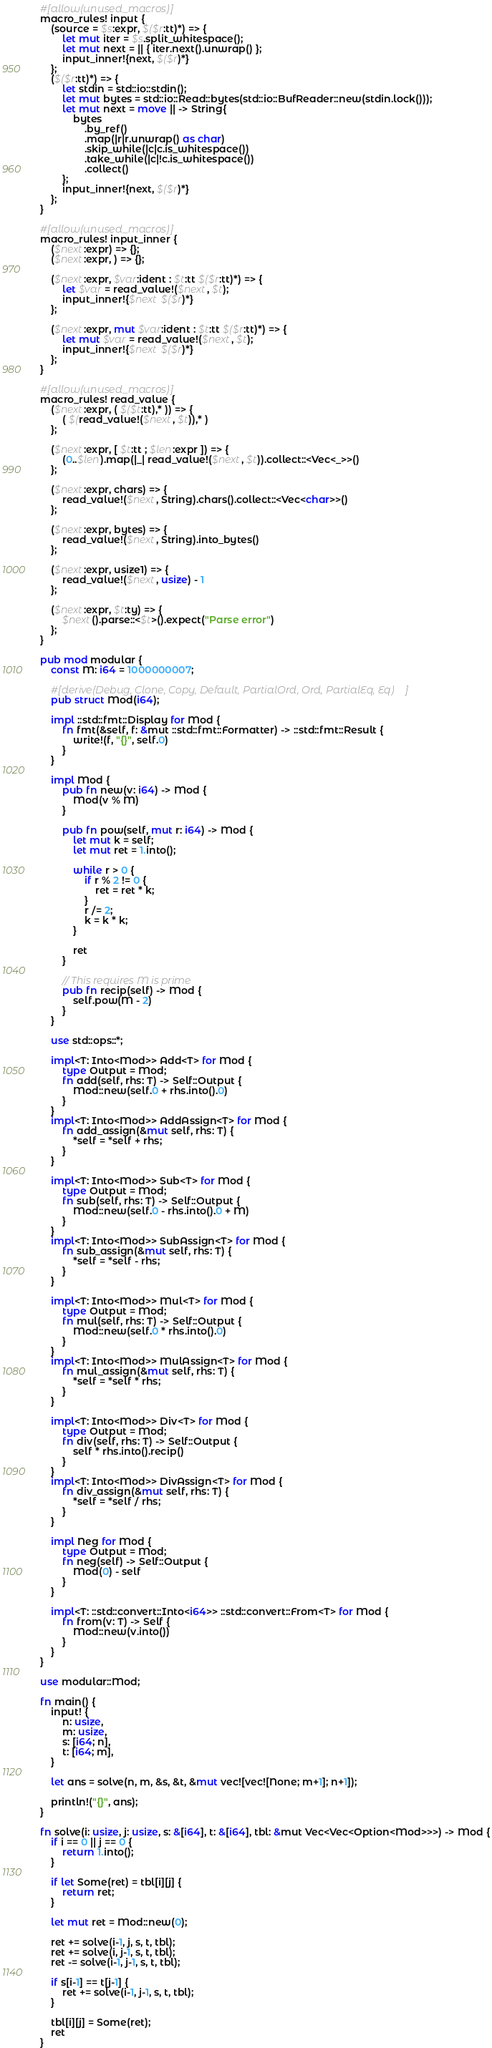Convert code to text. <code><loc_0><loc_0><loc_500><loc_500><_Rust_>#[allow(unused_macros)]
macro_rules! input {
    (source = $s:expr, $($r:tt)*) => {
        let mut iter = $s.split_whitespace();
        let mut next = || { iter.next().unwrap() };
        input_inner!{next, $($r)*}
    };
    ($($r:tt)*) => {
        let stdin = std::io::stdin();
        let mut bytes = std::io::Read::bytes(std::io::BufReader::new(stdin.lock()));
        let mut next = move || -> String{
            bytes
                .by_ref()
                .map(|r|r.unwrap() as char)
                .skip_while(|c|c.is_whitespace())
                .take_while(|c|!c.is_whitespace())
                .collect()
        };
        input_inner!{next, $($r)*}
    };
}

#[allow(unused_macros)]
macro_rules! input_inner {
    ($next:expr) => {};
    ($next:expr, ) => {};

    ($next:expr, $var:ident : $t:tt $($r:tt)*) => {
        let $var = read_value!($next, $t);
        input_inner!{$next $($r)*}
    };

    ($next:expr, mut $var:ident : $t:tt $($r:tt)*) => {
        let mut $var = read_value!($next, $t);
        input_inner!{$next $($r)*}
    };
}

#[allow(unused_macros)]
macro_rules! read_value {
    ($next:expr, ( $($t:tt),* )) => {
        ( $(read_value!($next, $t)),* )
    };

    ($next:expr, [ $t:tt ; $len:expr ]) => {
        (0..$len).map(|_| read_value!($next, $t)).collect::<Vec<_>>()
    };

    ($next:expr, chars) => {
        read_value!($next, String).chars().collect::<Vec<char>>()
    };

    ($next:expr, bytes) => {
        read_value!($next, String).into_bytes()
    };

    ($next:expr, usize1) => {
        read_value!($next, usize) - 1
    };

    ($next:expr, $t:ty) => {
        $next().parse::<$t>().expect("Parse error")
    };
}

pub mod modular {
    const M: i64 = 1000000007;

    #[derive(Debug, Clone, Copy, Default, PartialOrd, Ord, PartialEq, Eq)]
    pub struct Mod(i64);

    impl ::std::fmt::Display for Mod {
        fn fmt(&self, f: &mut ::std::fmt::Formatter) -> ::std::fmt::Result {
            write!(f, "{}", self.0)
        }
    }

    impl Mod {
        pub fn new(v: i64) -> Mod {
            Mod(v % M)
        }

        pub fn pow(self, mut r: i64) -> Mod {
            let mut k = self;
            let mut ret = 1.into();

            while r > 0 {
                if r % 2 != 0 {
                    ret = ret * k;
                }
                r /= 2;
                k = k * k;
            }

            ret
        }

        // This requires M is prime
        pub fn recip(self) -> Mod {
            self.pow(M - 2)
        }
    }

    use std::ops::*;

    impl<T: Into<Mod>> Add<T> for Mod {
        type Output = Mod;
        fn add(self, rhs: T) -> Self::Output {
            Mod::new(self.0 + rhs.into().0)
        }
    }
    impl<T: Into<Mod>> AddAssign<T> for Mod {
        fn add_assign(&mut self, rhs: T) {
            *self = *self + rhs;
        }
    }

    impl<T: Into<Mod>> Sub<T> for Mod {
        type Output = Mod;
        fn sub(self, rhs: T) -> Self::Output {
            Mod::new(self.0 - rhs.into().0 + M)
        }
    }
    impl<T: Into<Mod>> SubAssign<T> for Mod {
        fn sub_assign(&mut self, rhs: T) {
            *self = *self - rhs;
        }
    }

    impl<T: Into<Mod>> Mul<T> for Mod {
        type Output = Mod;
        fn mul(self, rhs: T) -> Self::Output {
            Mod::new(self.0 * rhs.into().0)
        }
    }
    impl<T: Into<Mod>> MulAssign<T> for Mod {
        fn mul_assign(&mut self, rhs: T) {
            *self = *self * rhs;
        }
    }

    impl<T: Into<Mod>> Div<T> for Mod {
        type Output = Mod;
        fn div(self, rhs: T) -> Self::Output {
            self * rhs.into().recip()
        }
    }
    impl<T: Into<Mod>> DivAssign<T> for Mod {
        fn div_assign(&mut self, rhs: T) {
            *self = *self / rhs;
        }
    }

    impl Neg for Mod {
        type Output = Mod;
        fn neg(self) -> Self::Output {
            Mod(0) - self
        }
    }

    impl<T: ::std::convert::Into<i64>> ::std::convert::From<T> for Mod {
        fn from(v: T) -> Self {
            Mod::new(v.into())
        }
    }
}

use modular::Mod;

fn main() {
    input! {
        n: usize,
        m: usize,
        s: [i64; n],
        t: [i64; m],
    }

    let ans = solve(n, m, &s, &t, &mut vec![vec![None; m+1]; n+1]);

    println!("{}", ans);
}

fn solve(i: usize, j: usize, s: &[i64], t: &[i64], tbl: &mut Vec<Vec<Option<Mod>>>) -> Mod {
    if i == 0 || j == 0 {
        return 1.into();
    }

    if let Some(ret) = tbl[i][j] {
        return ret;
    }

    let mut ret = Mod::new(0);

    ret += solve(i-1, j, s, t, tbl);
    ret += solve(i, j-1, s, t, tbl);
    ret -= solve(i-1, j-1, s, t, tbl);

    if s[i-1] == t[j-1] {
        ret += solve(i-1, j-1, s, t, tbl);
    }

    tbl[i][j] = Some(ret);
    ret
}</code> 